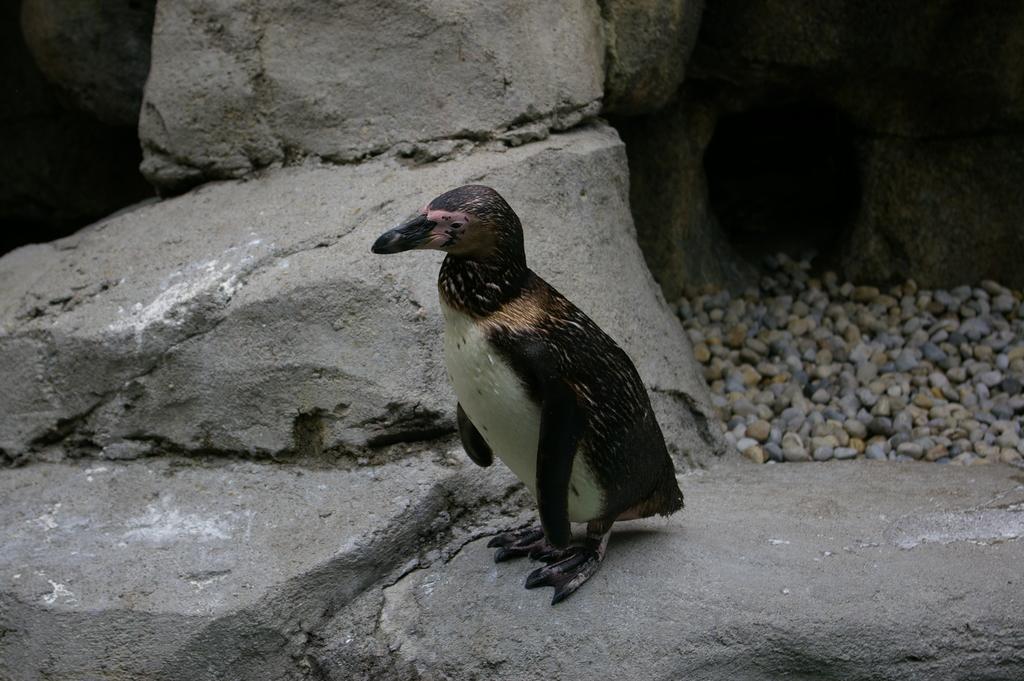How would you summarize this image in a sentence or two? In the middle of the image there is a bird on the rock. On the right side there are some stones. 